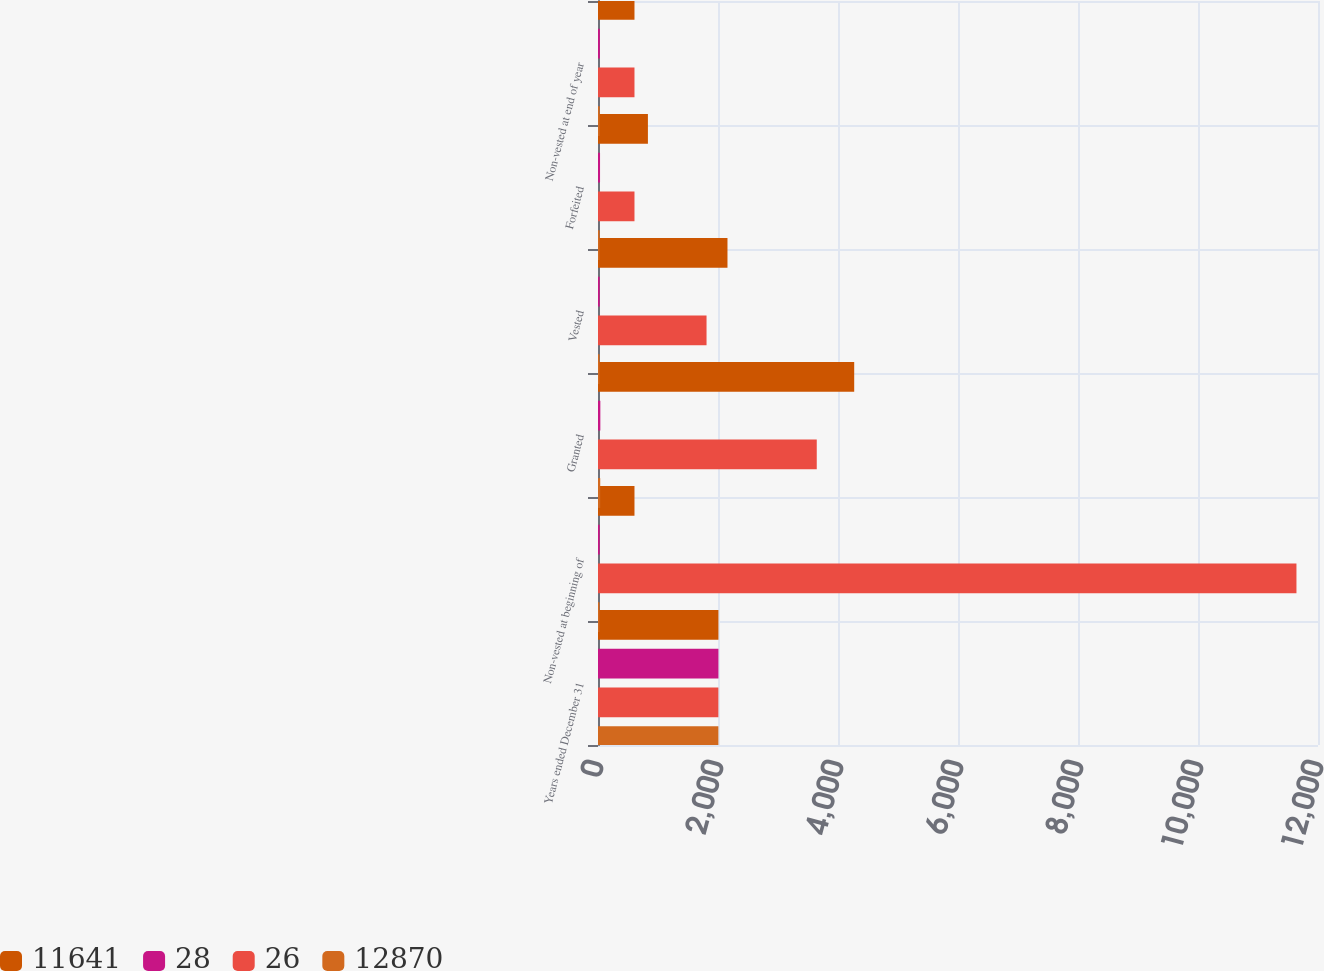Convert chart to OTSL. <chart><loc_0><loc_0><loc_500><loc_500><stacked_bar_chart><ecel><fcel>Years ended December 31<fcel>Non-vested at beginning of<fcel>Granted<fcel>Vested<fcel>Forfeited<fcel>Non-vested at end of year<nl><fcel>11641<fcel>2007<fcel>608<fcel>4270<fcel>2158<fcel>832<fcel>608<nl><fcel>28<fcel>2007<fcel>28<fcel>39<fcel>28<fcel>34<fcel>31<nl><fcel>26<fcel>2006<fcel>11641<fcel>3646<fcel>1809<fcel>608<fcel>608<nl><fcel>12870<fcel>2006<fcel>25<fcel>37<fcel>25<fcel>27<fcel>28<nl></chart> 